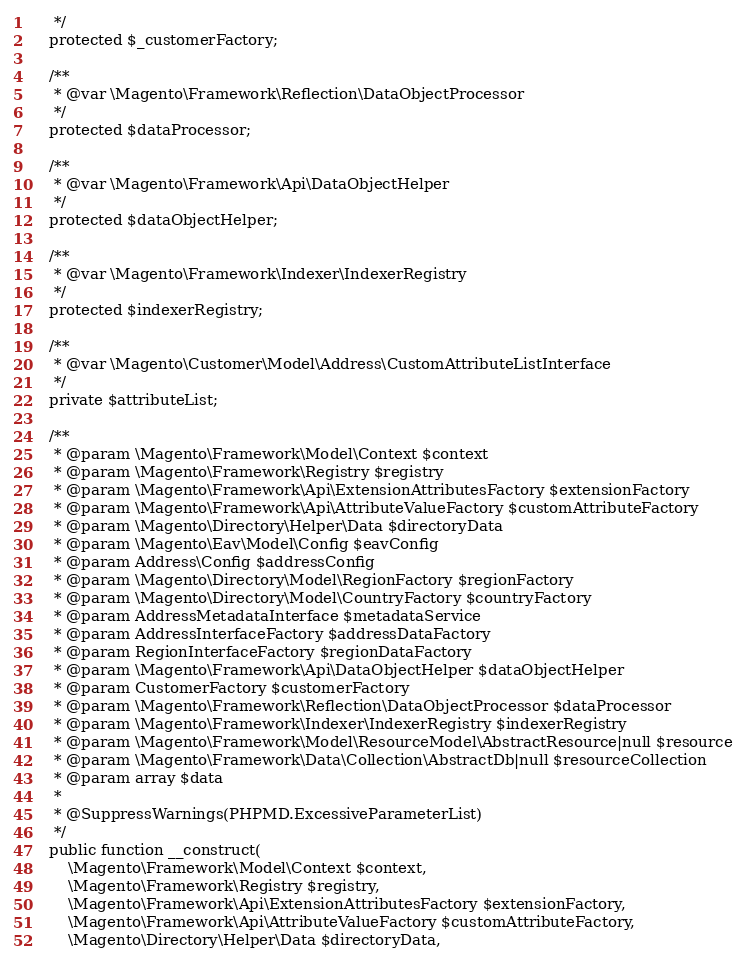<code> <loc_0><loc_0><loc_500><loc_500><_PHP_>     */
    protected $_customerFactory;

    /**
     * @var \Magento\Framework\Reflection\DataObjectProcessor
     */
    protected $dataProcessor;

    /**
     * @var \Magento\Framework\Api\DataObjectHelper
     */
    protected $dataObjectHelper;

    /**
     * @var \Magento\Framework\Indexer\IndexerRegistry
     */
    protected $indexerRegistry;

    /**
     * @var \Magento\Customer\Model\Address\CustomAttributeListInterface
     */
    private $attributeList;

    /**
     * @param \Magento\Framework\Model\Context $context
     * @param \Magento\Framework\Registry $registry
     * @param \Magento\Framework\Api\ExtensionAttributesFactory $extensionFactory
     * @param \Magento\Framework\Api\AttributeValueFactory $customAttributeFactory
     * @param \Magento\Directory\Helper\Data $directoryData
     * @param \Magento\Eav\Model\Config $eavConfig
     * @param Address\Config $addressConfig
     * @param \Magento\Directory\Model\RegionFactory $regionFactory
     * @param \Magento\Directory\Model\CountryFactory $countryFactory
     * @param AddressMetadataInterface $metadataService
     * @param AddressInterfaceFactory $addressDataFactory
     * @param RegionInterfaceFactory $regionDataFactory
     * @param \Magento\Framework\Api\DataObjectHelper $dataObjectHelper
     * @param CustomerFactory $customerFactory
     * @param \Magento\Framework\Reflection\DataObjectProcessor $dataProcessor
     * @param \Magento\Framework\Indexer\IndexerRegistry $indexerRegistry
     * @param \Magento\Framework\Model\ResourceModel\AbstractResource|null $resource
     * @param \Magento\Framework\Data\Collection\AbstractDb|null $resourceCollection
     * @param array $data
     *
     * @SuppressWarnings(PHPMD.ExcessiveParameterList)
     */
    public function __construct(
        \Magento\Framework\Model\Context $context,
        \Magento\Framework\Registry $registry,
        \Magento\Framework\Api\ExtensionAttributesFactory $extensionFactory,
        \Magento\Framework\Api\AttributeValueFactory $customAttributeFactory,
        \Magento\Directory\Helper\Data $directoryData,</code> 